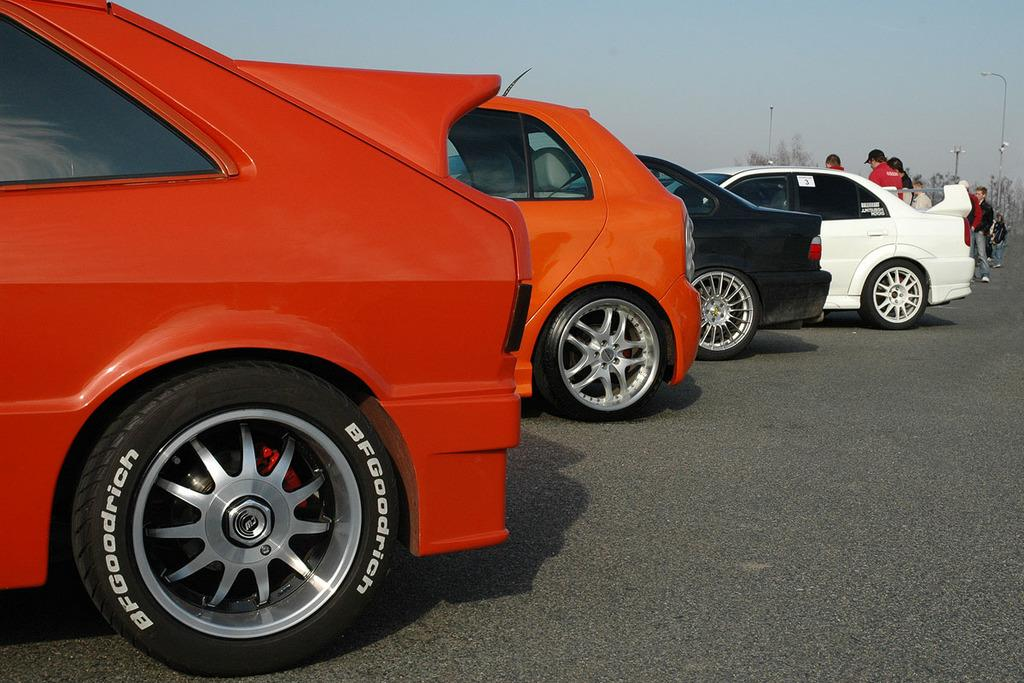What can be seen on the road in the image? There are cars on the road in the image. What else is visible in the background of the image? There are people and a light pole in the background of the image. Is there a plantation visible in the image? No, there is no plantation present in the image. What is the tendency of the desk in the image? There is no desk present in the image, so it is not possible to determine its tendency. 